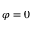<formula> <loc_0><loc_0><loc_500><loc_500>\varphi = 0</formula> 